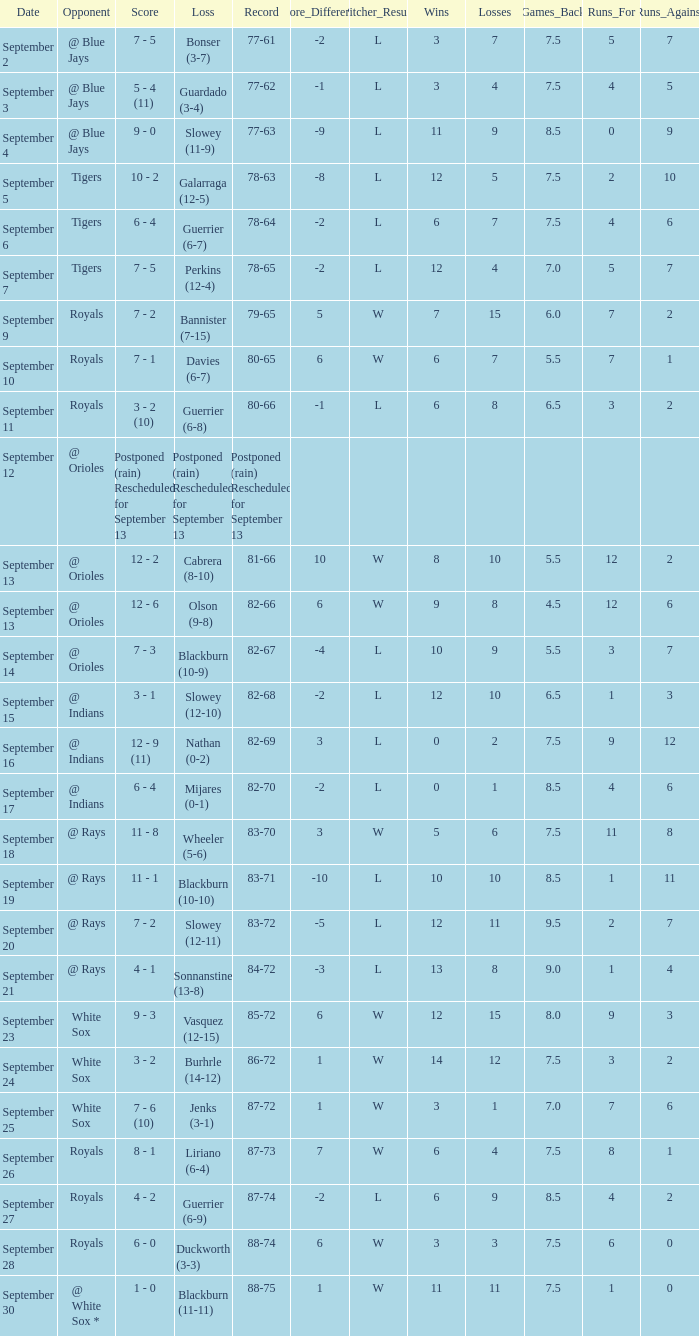What score has the opponent of tigers and a record of 78-64? 6 - 4. 